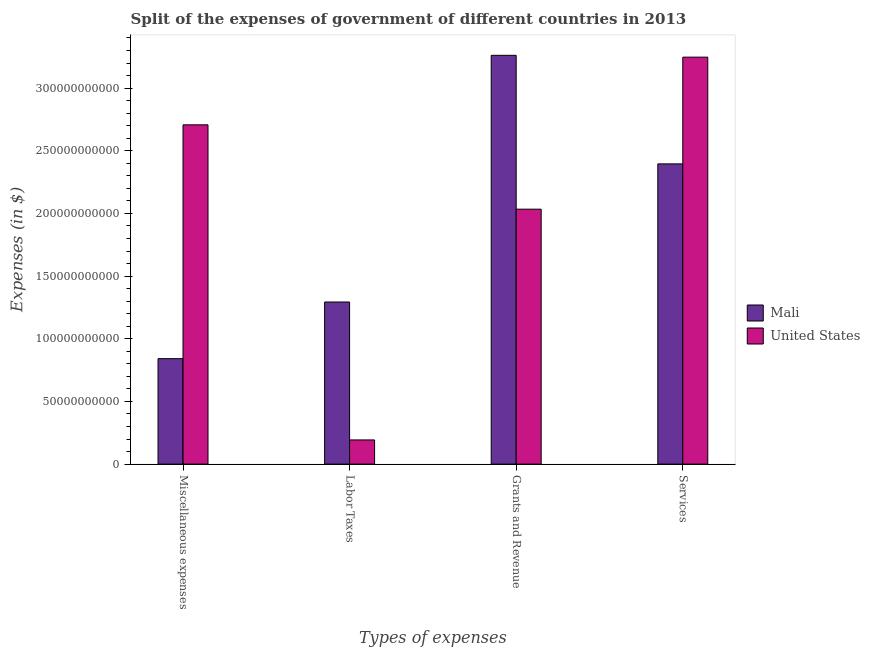How many groups of bars are there?
Provide a succinct answer. 4. Are the number of bars per tick equal to the number of legend labels?
Provide a succinct answer. Yes. How many bars are there on the 1st tick from the left?
Your response must be concise. 2. What is the label of the 2nd group of bars from the left?
Give a very brief answer. Labor Taxes. What is the amount spent on services in Mali?
Provide a short and direct response. 2.40e+11. Across all countries, what is the maximum amount spent on miscellaneous expenses?
Your answer should be very brief. 2.71e+11. Across all countries, what is the minimum amount spent on labor taxes?
Provide a short and direct response. 1.93e+1. In which country was the amount spent on services maximum?
Offer a terse response. United States. In which country was the amount spent on services minimum?
Make the answer very short. Mali. What is the total amount spent on miscellaneous expenses in the graph?
Keep it short and to the point. 3.55e+11. What is the difference between the amount spent on miscellaneous expenses in Mali and that in United States?
Your response must be concise. -1.87e+11. What is the difference between the amount spent on services in Mali and the amount spent on miscellaneous expenses in United States?
Your response must be concise. -3.12e+1. What is the average amount spent on services per country?
Keep it short and to the point. 2.82e+11. What is the difference between the amount spent on grants and revenue and amount spent on miscellaneous expenses in United States?
Provide a succinct answer. -6.73e+1. What is the ratio of the amount spent on labor taxes in Mali to that in United States?
Provide a short and direct response. 6.7. Is the amount spent on grants and revenue in Mali less than that in United States?
Keep it short and to the point. No. What is the difference between the highest and the second highest amount spent on labor taxes?
Offer a very short reply. 1.10e+11. What is the difference between the highest and the lowest amount spent on services?
Provide a succinct answer. 8.52e+1. In how many countries, is the amount spent on miscellaneous expenses greater than the average amount spent on miscellaneous expenses taken over all countries?
Provide a short and direct response. 1. Is it the case that in every country, the sum of the amount spent on services and amount spent on miscellaneous expenses is greater than the sum of amount spent on labor taxes and amount spent on grants and revenue?
Your answer should be compact. No. What does the 2nd bar from the left in Grants and Revenue represents?
Make the answer very short. United States. Is it the case that in every country, the sum of the amount spent on miscellaneous expenses and amount spent on labor taxes is greater than the amount spent on grants and revenue?
Provide a short and direct response. No. How many bars are there?
Your answer should be compact. 8. Are all the bars in the graph horizontal?
Offer a terse response. No. How many countries are there in the graph?
Your answer should be compact. 2. Are the values on the major ticks of Y-axis written in scientific E-notation?
Give a very brief answer. No. Does the graph contain grids?
Offer a very short reply. No. Where does the legend appear in the graph?
Offer a terse response. Center right. How many legend labels are there?
Offer a very short reply. 2. What is the title of the graph?
Provide a succinct answer. Split of the expenses of government of different countries in 2013. Does "Guinea" appear as one of the legend labels in the graph?
Your answer should be compact. No. What is the label or title of the X-axis?
Offer a terse response. Types of expenses. What is the label or title of the Y-axis?
Make the answer very short. Expenses (in $). What is the Expenses (in $) of Mali in Miscellaneous expenses?
Make the answer very short. 8.41e+1. What is the Expenses (in $) of United States in Miscellaneous expenses?
Your response must be concise. 2.71e+11. What is the Expenses (in $) of Mali in Labor Taxes?
Provide a short and direct response. 1.29e+11. What is the Expenses (in $) of United States in Labor Taxes?
Ensure brevity in your answer.  1.93e+1. What is the Expenses (in $) in Mali in Grants and Revenue?
Offer a very short reply. 3.26e+11. What is the Expenses (in $) in United States in Grants and Revenue?
Offer a very short reply. 2.03e+11. What is the Expenses (in $) in Mali in Services?
Your response must be concise. 2.40e+11. What is the Expenses (in $) in United States in Services?
Your answer should be compact. 3.25e+11. Across all Types of expenses, what is the maximum Expenses (in $) in Mali?
Make the answer very short. 3.26e+11. Across all Types of expenses, what is the maximum Expenses (in $) in United States?
Your answer should be very brief. 3.25e+11. Across all Types of expenses, what is the minimum Expenses (in $) in Mali?
Keep it short and to the point. 8.41e+1. Across all Types of expenses, what is the minimum Expenses (in $) in United States?
Your answer should be compact. 1.93e+1. What is the total Expenses (in $) in Mali in the graph?
Your response must be concise. 7.79e+11. What is the total Expenses (in $) of United States in the graph?
Your answer should be very brief. 8.18e+11. What is the difference between the Expenses (in $) of Mali in Miscellaneous expenses and that in Labor Taxes?
Keep it short and to the point. -4.52e+1. What is the difference between the Expenses (in $) of United States in Miscellaneous expenses and that in Labor Taxes?
Provide a succinct answer. 2.51e+11. What is the difference between the Expenses (in $) in Mali in Miscellaneous expenses and that in Grants and Revenue?
Make the answer very short. -2.42e+11. What is the difference between the Expenses (in $) in United States in Miscellaneous expenses and that in Grants and Revenue?
Keep it short and to the point. 6.73e+1. What is the difference between the Expenses (in $) of Mali in Miscellaneous expenses and that in Services?
Make the answer very short. -1.55e+11. What is the difference between the Expenses (in $) of United States in Miscellaneous expenses and that in Services?
Make the answer very short. -5.40e+1. What is the difference between the Expenses (in $) in Mali in Labor Taxes and that in Grants and Revenue?
Provide a succinct answer. -1.97e+11. What is the difference between the Expenses (in $) of United States in Labor Taxes and that in Grants and Revenue?
Give a very brief answer. -1.84e+11. What is the difference between the Expenses (in $) of Mali in Labor Taxes and that in Services?
Provide a short and direct response. -1.10e+11. What is the difference between the Expenses (in $) in United States in Labor Taxes and that in Services?
Keep it short and to the point. -3.05e+11. What is the difference between the Expenses (in $) of Mali in Grants and Revenue and that in Services?
Make the answer very short. 8.66e+1. What is the difference between the Expenses (in $) of United States in Grants and Revenue and that in Services?
Give a very brief answer. -1.21e+11. What is the difference between the Expenses (in $) in Mali in Miscellaneous expenses and the Expenses (in $) in United States in Labor Taxes?
Keep it short and to the point. 6.48e+1. What is the difference between the Expenses (in $) of Mali in Miscellaneous expenses and the Expenses (in $) of United States in Grants and Revenue?
Offer a terse response. -1.19e+11. What is the difference between the Expenses (in $) in Mali in Miscellaneous expenses and the Expenses (in $) in United States in Services?
Offer a terse response. -2.41e+11. What is the difference between the Expenses (in $) of Mali in Labor Taxes and the Expenses (in $) of United States in Grants and Revenue?
Provide a succinct answer. -7.41e+1. What is the difference between the Expenses (in $) in Mali in Labor Taxes and the Expenses (in $) in United States in Services?
Your answer should be very brief. -1.95e+11. What is the difference between the Expenses (in $) of Mali in Grants and Revenue and the Expenses (in $) of United States in Services?
Ensure brevity in your answer.  1.47e+09. What is the average Expenses (in $) of Mali per Types of expenses?
Your answer should be compact. 1.95e+11. What is the average Expenses (in $) of United States per Types of expenses?
Your answer should be compact. 2.05e+11. What is the difference between the Expenses (in $) in Mali and Expenses (in $) in United States in Miscellaneous expenses?
Your answer should be very brief. -1.87e+11. What is the difference between the Expenses (in $) of Mali and Expenses (in $) of United States in Labor Taxes?
Offer a very short reply. 1.10e+11. What is the difference between the Expenses (in $) of Mali and Expenses (in $) of United States in Grants and Revenue?
Your answer should be very brief. 1.23e+11. What is the difference between the Expenses (in $) of Mali and Expenses (in $) of United States in Services?
Ensure brevity in your answer.  -8.52e+1. What is the ratio of the Expenses (in $) of Mali in Miscellaneous expenses to that in Labor Taxes?
Your response must be concise. 0.65. What is the ratio of the Expenses (in $) of United States in Miscellaneous expenses to that in Labor Taxes?
Provide a succinct answer. 14.03. What is the ratio of the Expenses (in $) in Mali in Miscellaneous expenses to that in Grants and Revenue?
Make the answer very short. 0.26. What is the ratio of the Expenses (in $) in United States in Miscellaneous expenses to that in Grants and Revenue?
Keep it short and to the point. 1.33. What is the ratio of the Expenses (in $) of Mali in Miscellaneous expenses to that in Services?
Offer a very short reply. 0.35. What is the ratio of the Expenses (in $) in United States in Miscellaneous expenses to that in Services?
Provide a short and direct response. 0.83. What is the ratio of the Expenses (in $) in Mali in Labor Taxes to that in Grants and Revenue?
Make the answer very short. 0.4. What is the ratio of the Expenses (in $) in United States in Labor Taxes to that in Grants and Revenue?
Your answer should be compact. 0.09. What is the ratio of the Expenses (in $) of Mali in Labor Taxes to that in Services?
Your answer should be very brief. 0.54. What is the ratio of the Expenses (in $) in United States in Labor Taxes to that in Services?
Offer a very short reply. 0.06. What is the ratio of the Expenses (in $) of Mali in Grants and Revenue to that in Services?
Your response must be concise. 1.36. What is the ratio of the Expenses (in $) of United States in Grants and Revenue to that in Services?
Offer a terse response. 0.63. What is the difference between the highest and the second highest Expenses (in $) in Mali?
Ensure brevity in your answer.  8.66e+1. What is the difference between the highest and the second highest Expenses (in $) in United States?
Your response must be concise. 5.40e+1. What is the difference between the highest and the lowest Expenses (in $) of Mali?
Your response must be concise. 2.42e+11. What is the difference between the highest and the lowest Expenses (in $) in United States?
Make the answer very short. 3.05e+11. 